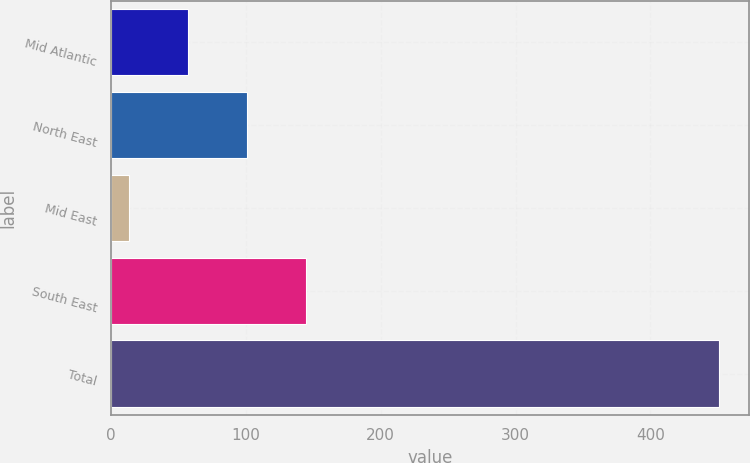<chart> <loc_0><loc_0><loc_500><loc_500><bar_chart><fcel>Mid Atlantic<fcel>North East<fcel>Mid East<fcel>South East<fcel>Total<nl><fcel>57.25<fcel>101<fcel>13.5<fcel>144.75<fcel>451<nl></chart> 